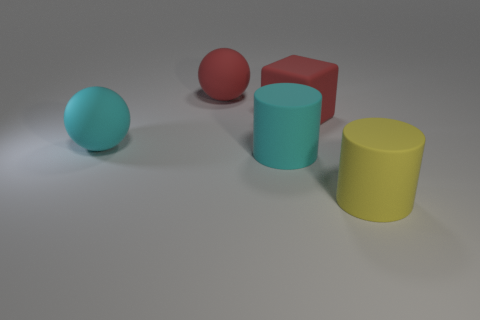Subtract all cylinders. How many objects are left? 3 Add 3 big yellow spheres. How many objects exist? 8 Subtract all gray cubes. How many cyan cylinders are left? 1 Add 1 cyan rubber cylinders. How many cyan rubber cylinders are left? 2 Add 3 large yellow rubber cylinders. How many large yellow rubber cylinders exist? 4 Subtract 0 yellow balls. How many objects are left? 5 Subtract 1 cylinders. How many cylinders are left? 1 Subtract all brown spheres. Subtract all purple cylinders. How many spheres are left? 2 Subtract all big cyan rubber balls. Subtract all large cyan matte spheres. How many objects are left? 3 